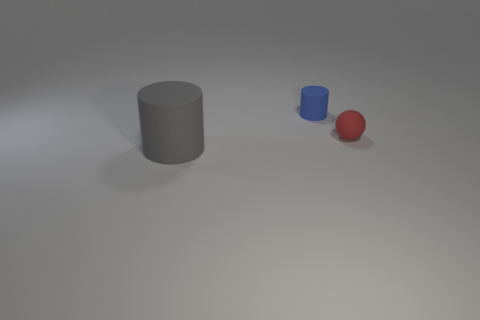Add 1 tiny yellow rubber blocks. How many objects exist? 4 Subtract all spheres. How many objects are left? 2 Add 1 balls. How many balls are left? 2 Add 1 small red balls. How many small red balls exist? 2 Subtract 0 green blocks. How many objects are left? 3 Subtract all blue matte cylinders. Subtract all tiny matte things. How many objects are left? 0 